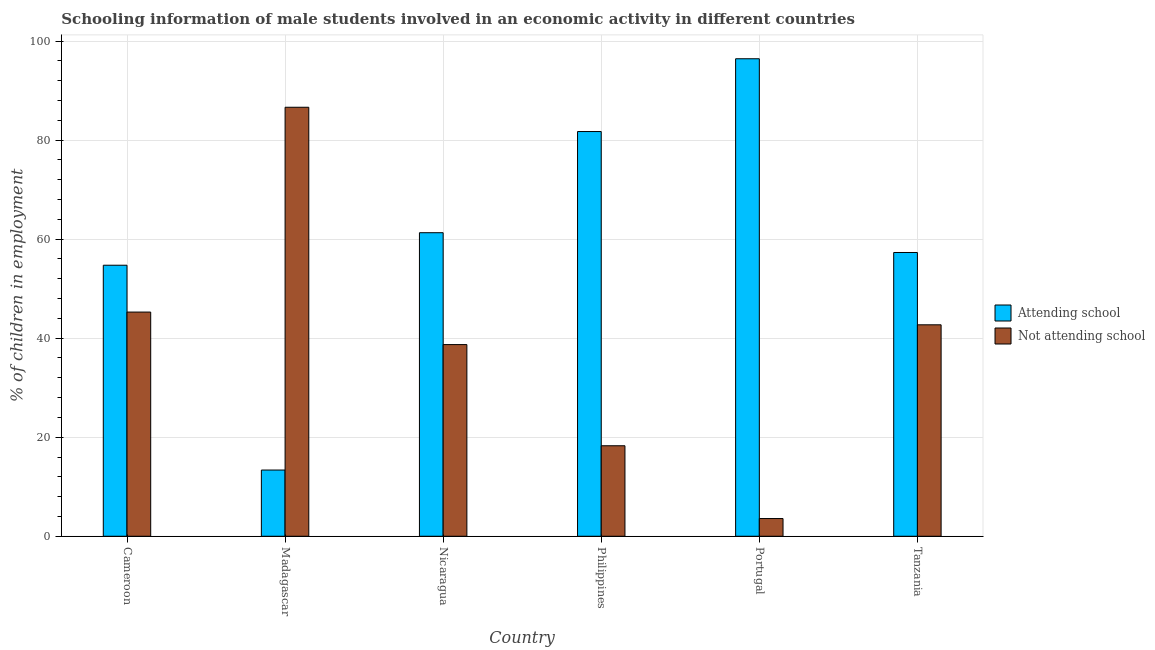How many groups of bars are there?
Your response must be concise. 6. What is the label of the 1st group of bars from the left?
Provide a succinct answer. Cameroon. What is the percentage of employed males who are attending school in Madagascar?
Your response must be concise. 13.37. Across all countries, what is the maximum percentage of employed males who are attending school?
Provide a short and direct response. 96.42. Across all countries, what is the minimum percentage of employed males who are not attending school?
Provide a short and direct response. 3.58. In which country was the percentage of employed males who are not attending school maximum?
Make the answer very short. Madagascar. In which country was the percentage of employed males who are attending school minimum?
Ensure brevity in your answer.  Madagascar. What is the total percentage of employed males who are attending school in the graph?
Provide a succinct answer. 364.85. What is the difference between the percentage of employed males who are not attending school in Philippines and that in Tanzania?
Provide a short and direct response. -24.42. What is the difference between the percentage of employed males who are not attending school in Madagascar and the percentage of employed males who are attending school in Cameroon?
Provide a succinct answer. 31.9. What is the average percentage of employed males who are attending school per country?
Offer a very short reply. 60.81. What is the difference between the percentage of employed males who are not attending school and percentage of employed males who are attending school in Portugal?
Provide a succinct answer. -92.85. In how many countries, is the percentage of employed males who are not attending school greater than 44 %?
Offer a very short reply. 2. What is the ratio of the percentage of employed males who are not attending school in Madagascar to that in Portugal?
Ensure brevity in your answer.  24.22. Is the percentage of employed males who are attending school in Madagascar less than that in Nicaragua?
Your response must be concise. Yes. What is the difference between the highest and the second highest percentage of employed males who are attending school?
Provide a short and direct response. 14.7. What is the difference between the highest and the lowest percentage of employed males who are not attending school?
Make the answer very short. 83.05. In how many countries, is the percentage of employed males who are attending school greater than the average percentage of employed males who are attending school taken over all countries?
Give a very brief answer. 3. What does the 2nd bar from the left in Cameroon represents?
Give a very brief answer. Not attending school. What does the 2nd bar from the right in Madagascar represents?
Make the answer very short. Attending school. How many bars are there?
Give a very brief answer. 12. Are all the bars in the graph horizontal?
Your answer should be compact. No. Are the values on the major ticks of Y-axis written in scientific E-notation?
Offer a very short reply. No. Does the graph contain any zero values?
Keep it short and to the point. No. Does the graph contain grids?
Your answer should be compact. Yes. How many legend labels are there?
Your response must be concise. 2. What is the title of the graph?
Provide a succinct answer. Schooling information of male students involved in an economic activity in different countries. Does "Travel services" appear as one of the legend labels in the graph?
Your answer should be very brief. No. What is the label or title of the Y-axis?
Make the answer very short. % of children in employment. What is the % of children in employment of Attending school in Cameroon?
Your answer should be very brief. 54.73. What is the % of children in employment of Not attending school in Cameroon?
Your response must be concise. 45.27. What is the % of children in employment of Attending school in Madagascar?
Offer a very short reply. 13.37. What is the % of children in employment of Not attending school in Madagascar?
Your response must be concise. 86.63. What is the % of children in employment of Attending school in Nicaragua?
Provide a succinct answer. 61.3. What is the % of children in employment of Not attending school in Nicaragua?
Keep it short and to the point. 38.7. What is the % of children in employment of Attending school in Philippines?
Offer a very short reply. 81.73. What is the % of children in employment of Not attending school in Philippines?
Keep it short and to the point. 18.27. What is the % of children in employment in Attending school in Portugal?
Offer a very short reply. 96.42. What is the % of children in employment of Not attending school in Portugal?
Provide a succinct answer. 3.58. What is the % of children in employment of Attending school in Tanzania?
Provide a succinct answer. 57.3. What is the % of children in employment of Not attending school in Tanzania?
Your answer should be very brief. 42.7. Across all countries, what is the maximum % of children in employment of Attending school?
Provide a succinct answer. 96.42. Across all countries, what is the maximum % of children in employment of Not attending school?
Offer a very short reply. 86.63. Across all countries, what is the minimum % of children in employment in Attending school?
Offer a terse response. 13.37. Across all countries, what is the minimum % of children in employment of Not attending school?
Provide a short and direct response. 3.58. What is the total % of children in employment of Attending school in the graph?
Your response must be concise. 364.85. What is the total % of children in employment of Not attending school in the graph?
Offer a very short reply. 235.15. What is the difference between the % of children in employment in Attending school in Cameroon and that in Madagascar?
Give a very brief answer. 41.36. What is the difference between the % of children in employment in Not attending school in Cameroon and that in Madagascar?
Offer a very short reply. -41.36. What is the difference between the % of children in employment of Attending school in Cameroon and that in Nicaragua?
Your answer should be very brief. -6.57. What is the difference between the % of children in employment in Not attending school in Cameroon and that in Nicaragua?
Ensure brevity in your answer.  6.57. What is the difference between the % of children in employment of Attending school in Cameroon and that in Philippines?
Your answer should be compact. -27. What is the difference between the % of children in employment of Not attending school in Cameroon and that in Philippines?
Offer a very short reply. 27. What is the difference between the % of children in employment in Attending school in Cameroon and that in Portugal?
Provide a short and direct response. -41.69. What is the difference between the % of children in employment in Not attending school in Cameroon and that in Portugal?
Your answer should be compact. 41.69. What is the difference between the % of children in employment in Attending school in Cameroon and that in Tanzania?
Offer a terse response. -2.57. What is the difference between the % of children in employment in Not attending school in Cameroon and that in Tanzania?
Make the answer very short. 2.57. What is the difference between the % of children in employment of Attending school in Madagascar and that in Nicaragua?
Your response must be concise. -47.93. What is the difference between the % of children in employment of Not attending school in Madagascar and that in Nicaragua?
Your answer should be compact. 47.93. What is the difference between the % of children in employment in Attending school in Madagascar and that in Philippines?
Your response must be concise. -68.36. What is the difference between the % of children in employment in Not attending school in Madagascar and that in Philippines?
Give a very brief answer. 68.36. What is the difference between the % of children in employment of Attending school in Madagascar and that in Portugal?
Offer a very short reply. -83.05. What is the difference between the % of children in employment in Not attending school in Madagascar and that in Portugal?
Provide a succinct answer. 83.05. What is the difference between the % of children in employment of Attending school in Madagascar and that in Tanzania?
Your response must be concise. -43.93. What is the difference between the % of children in employment in Not attending school in Madagascar and that in Tanzania?
Make the answer very short. 43.93. What is the difference between the % of children in employment in Attending school in Nicaragua and that in Philippines?
Give a very brief answer. -20.43. What is the difference between the % of children in employment in Not attending school in Nicaragua and that in Philippines?
Offer a very short reply. 20.43. What is the difference between the % of children in employment in Attending school in Nicaragua and that in Portugal?
Provide a succinct answer. -35.13. What is the difference between the % of children in employment of Not attending school in Nicaragua and that in Portugal?
Offer a terse response. 35.13. What is the difference between the % of children in employment of Attending school in Nicaragua and that in Tanzania?
Your answer should be compact. 3.99. What is the difference between the % of children in employment in Not attending school in Nicaragua and that in Tanzania?
Offer a terse response. -3.99. What is the difference between the % of children in employment in Attending school in Philippines and that in Portugal?
Make the answer very short. -14.7. What is the difference between the % of children in employment in Not attending school in Philippines and that in Portugal?
Your response must be concise. 14.7. What is the difference between the % of children in employment in Attending school in Philippines and that in Tanzania?
Your answer should be very brief. 24.42. What is the difference between the % of children in employment in Not attending school in Philippines and that in Tanzania?
Offer a terse response. -24.42. What is the difference between the % of children in employment of Attending school in Portugal and that in Tanzania?
Your response must be concise. 39.12. What is the difference between the % of children in employment of Not attending school in Portugal and that in Tanzania?
Your answer should be very brief. -39.12. What is the difference between the % of children in employment of Attending school in Cameroon and the % of children in employment of Not attending school in Madagascar?
Provide a succinct answer. -31.9. What is the difference between the % of children in employment in Attending school in Cameroon and the % of children in employment in Not attending school in Nicaragua?
Your answer should be very brief. 16.03. What is the difference between the % of children in employment of Attending school in Cameroon and the % of children in employment of Not attending school in Philippines?
Offer a very short reply. 36.46. What is the difference between the % of children in employment in Attending school in Cameroon and the % of children in employment in Not attending school in Portugal?
Provide a succinct answer. 51.15. What is the difference between the % of children in employment of Attending school in Cameroon and the % of children in employment of Not attending school in Tanzania?
Your response must be concise. 12.03. What is the difference between the % of children in employment in Attending school in Madagascar and the % of children in employment in Not attending school in Nicaragua?
Make the answer very short. -25.33. What is the difference between the % of children in employment in Attending school in Madagascar and the % of children in employment in Not attending school in Philippines?
Ensure brevity in your answer.  -4.9. What is the difference between the % of children in employment in Attending school in Madagascar and the % of children in employment in Not attending school in Portugal?
Keep it short and to the point. 9.79. What is the difference between the % of children in employment of Attending school in Madagascar and the % of children in employment of Not attending school in Tanzania?
Give a very brief answer. -29.33. What is the difference between the % of children in employment in Attending school in Nicaragua and the % of children in employment in Not attending school in Philippines?
Keep it short and to the point. 43.02. What is the difference between the % of children in employment in Attending school in Nicaragua and the % of children in employment in Not attending school in Portugal?
Your answer should be compact. 57.72. What is the difference between the % of children in employment of Attending school in Nicaragua and the % of children in employment of Not attending school in Tanzania?
Keep it short and to the point. 18.6. What is the difference between the % of children in employment of Attending school in Philippines and the % of children in employment of Not attending school in Portugal?
Offer a terse response. 78.15. What is the difference between the % of children in employment in Attending school in Philippines and the % of children in employment in Not attending school in Tanzania?
Keep it short and to the point. 39.03. What is the difference between the % of children in employment of Attending school in Portugal and the % of children in employment of Not attending school in Tanzania?
Your answer should be compact. 53.73. What is the average % of children in employment of Attending school per country?
Provide a succinct answer. 60.81. What is the average % of children in employment in Not attending school per country?
Offer a terse response. 39.19. What is the difference between the % of children in employment of Attending school and % of children in employment of Not attending school in Cameroon?
Offer a very short reply. 9.46. What is the difference between the % of children in employment in Attending school and % of children in employment in Not attending school in Madagascar?
Give a very brief answer. -73.26. What is the difference between the % of children in employment in Attending school and % of children in employment in Not attending school in Nicaragua?
Offer a very short reply. 22.59. What is the difference between the % of children in employment in Attending school and % of children in employment in Not attending school in Philippines?
Your answer should be compact. 63.45. What is the difference between the % of children in employment in Attending school and % of children in employment in Not attending school in Portugal?
Ensure brevity in your answer.  92.85. What is the difference between the % of children in employment of Attending school and % of children in employment of Not attending school in Tanzania?
Provide a short and direct response. 14.6. What is the ratio of the % of children in employment in Attending school in Cameroon to that in Madagascar?
Offer a terse response. 4.09. What is the ratio of the % of children in employment in Not attending school in Cameroon to that in Madagascar?
Keep it short and to the point. 0.52. What is the ratio of the % of children in employment of Attending school in Cameroon to that in Nicaragua?
Provide a short and direct response. 0.89. What is the ratio of the % of children in employment of Not attending school in Cameroon to that in Nicaragua?
Make the answer very short. 1.17. What is the ratio of the % of children in employment in Attending school in Cameroon to that in Philippines?
Offer a very short reply. 0.67. What is the ratio of the % of children in employment in Not attending school in Cameroon to that in Philippines?
Make the answer very short. 2.48. What is the ratio of the % of children in employment in Attending school in Cameroon to that in Portugal?
Your answer should be very brief. 0.57. What is the ratio of the % of children in employment in Not attending school in Cameroon to that in Portugal?
Offer a terse response. 12.66. What is the ratio of the % of children in employment of Attending school in Cameroon to that in Tanzania?
Offer a very short reply. 0.96. What is the ratio of the % of children in employment in Not attending school in Cameroon to that in Tanzania?
Your answer should be compact. 1.06. What is the ratio of the % of children in employment of Attending school in Madagascar to that in Nicaragua?
Provide a short and direct response. 0.22. What is the ratio of the % of children in employment in Not attending school in Madagascar to that in Nicaragua?
Provide a succinct answer. 2.24. What is the ratio of the % of children in employment of Attending school in Madagascar to that in Philippines?
Ensure brevity in your answer.  0.16. What is the ratio of the % of children in employment in Not attending school in Madagascar to that in Philippines?
Make the answer very short. 4.74. What is the ratio of the % of children in employment in Attending school in Madagascar to that in Portugal?
Ensure brevity in your answer.  0.14. What is the ratio of the % of children in employment of Not attending school in Madagascar to that in Portugal?
Offer a very short reply. 24.22. What is the ratio of the % of children in employment of Attending school in Madagascar to that in Tanzania?
Offer a terse response. 0.23. What is the ratio of the % of children in employment in Not attending school in Madagascar to that in Tanzania?
Give a very brief answer. 2.03. What is the ratio of the % of children in employment in Attending school in Nicaragua to that in Philippines?
Offer a very short reply. 0.75. What is the ratio of the % of children in employment of Not attending school in Nicaragua to that in Philippines?
Offer a very short reply. 2.12. What is the ratio of the % of children in employment of Attending school in Nicaragua to that in Portugal?
Offer a very short reply. 0.64. What is the ratio of the % of children in employment in Not attending school in Nicaragua to that in Portugal?
Make the answer very short. 10.82. What is the ratio of the % of children in employment of Attending school in Nicaragua to that in Tanzania?
Keep it short and to the point. 1.07. What is the ratio of the % of children in employment in Not attending school in Nicaragua to that in Tanzania?
Your answer should be very brief. 0.91. What is the ratio of the % of children in employment of Attending school in Philippines to that in Portugal?
Provide a short and direct response. 0.85. What is the ratio of the % of children in employment of Not attending school in Philippines to that in Portugal?
Offer a terse response. 5.11. What is the ratio of the % of children in employment in Attending school in Philippines to that in Tanzania?
Your response must be concise. 1.43. What is the ratio of the % of children in employment of Not attending school in Philippines to that in Tanzania?
Your response must be concise. 0.43. What is the ratio of the % of children in employment in Attending school in Portugal to that in Tanzania?
Make the answer very short. 1.68. What is the ratio of the % of children in employment of Not attending school in Portugal to that in Tanzania?
Your answer should be very brief. 0.08. What is the difference between the highest and the second highest % of children in employment of Attending school?
Give a very brief answer. 14.7. What is the difference between the highest and the second highest % of children in employment in Not attending school?
Give a very brief answer. 41.36. What is the difference between the highest and the lowest % of children in employment in Attending school?
Offer a very short reply. 83.05. What is the difference between the highest and the lowest % of children in employment in Not attending school?
Ensure brevity in your answer.  83.05. 